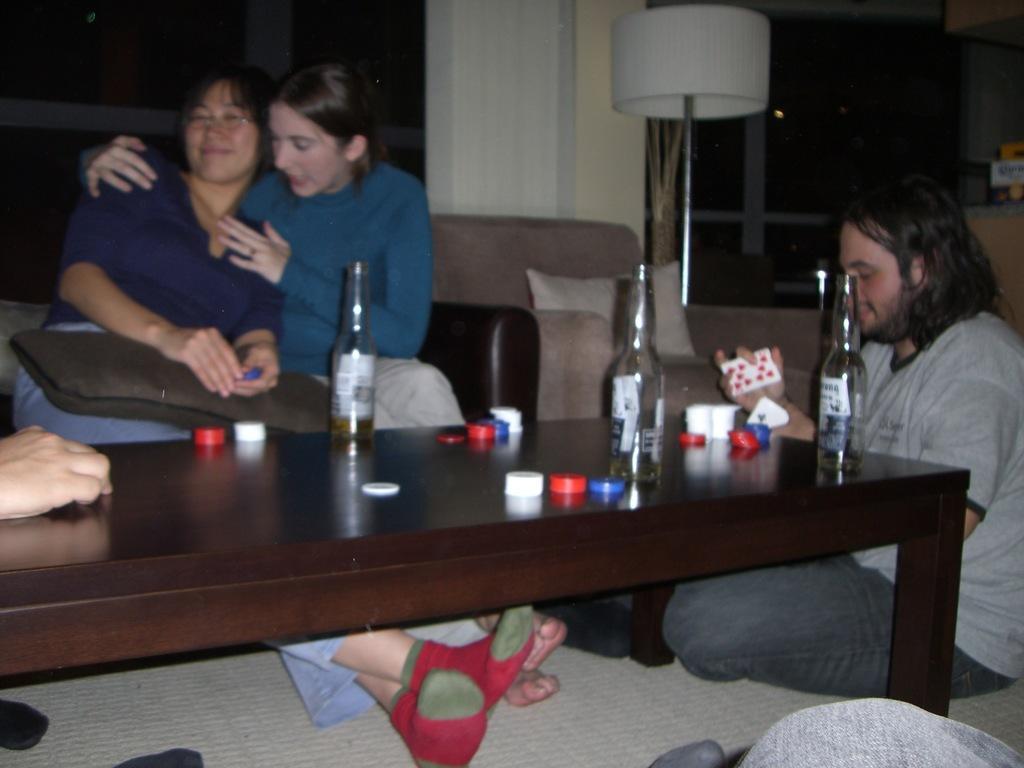Could you give a brief overview of what you see in this image? here in this picture we can see two woman sitting on the table and one person sitting on the floor here we can also see on the table we can see the bottle,here we can also see wall clock. 